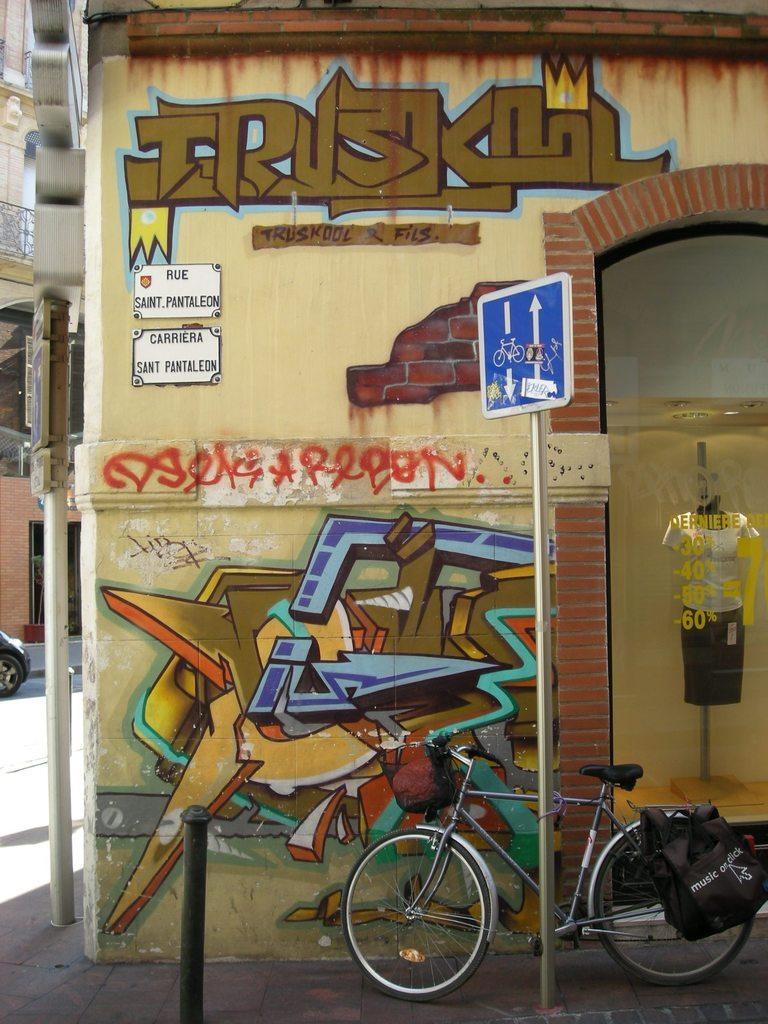In one or two sentences, can you explain what this image depicts? In this picture we can see poles, boards and bag on a bicycle. We can see painting and boards on the wall and glass, through this glass we can see mannequin with clothes. In the background of the image we can see building, railing and vehicle wheel. 